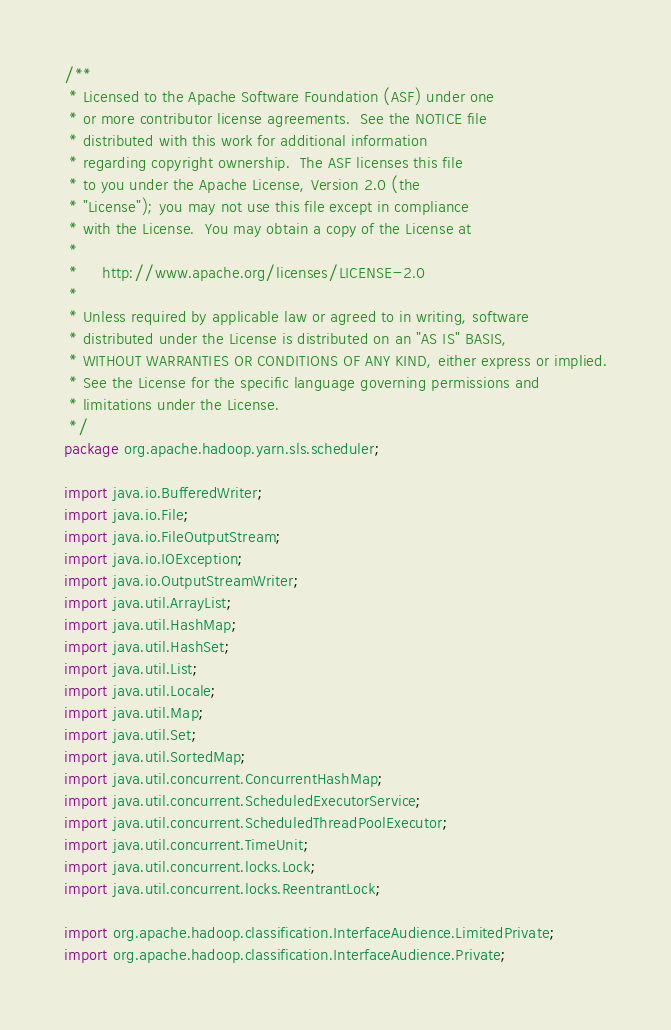Convert code to text. <code><loc_0><loc_0><loc_500><loc_500><_Java_>/**
 * Licensed to the Apache Software Foundation (ASF) under one
 * or more contributor license agreements.  See the NOTICE file
 * distributed with this work for additional information
 * regarding copyright ownership.  The ASF licenses this file
 * to you under the Apache License, Version 2.0 (the
 * "License"); you may not use this file except in compliance
 * with the License.  You may obtain a copy of the License at
 *
 *     http://www.apache.org/licenses/LICENSE-2.0
 *
 * Unless required by applicable law or agreed to in writing, software
 * distributed under the License is distributed on an "AS IS" BASIS,
 * WITHOUT WARRANTIES OR CONDITIONS OF ANY KIND, either express or implied.
 * See the License for the specific language governing permissions and
 * limitations under the License.
 */
package org.apache.hadoop.yarn.sls.scheduler;

import java.io.BufferedWriter;
import java.io.File;
import java.io.FileOutputStream;
import java.io.IOException;
import java.io.OutputStreamWriter;
import java.util.ArrayList;
import java.util.HashMap;
import java.util.HashSet;
import java.util.List;
import java.util.Locale;
import java.util.Map;
import java.util.Set;
import java.util.SortedMap;
import java.util.concurrent.ConcurrentHashMap;
import java.util.concurrent.ScheduledExecutorService;
import java.util.concurrent.ScheduledThreadPoolExecutor;
import java.util.concurrent.TimeUnit;
import java.util.concurrent.locks.Lock;
import java.util.concurrent.locks.ReentrantLock;

import org.apache.hadoop.classification.InterfaceAudience.LimitedPrivate;
import org.apache.hadoop.classification.InterfaceAudience.Private;</code> 